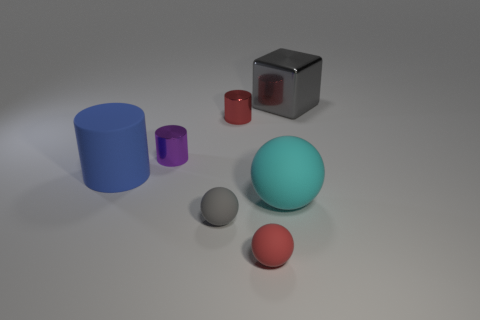There is a gray sphere; what number of tiny things are behind it?
Make the answer very short. 2. What number of things are either gray objects or objects to the left of the small red cylinder?
Give a very brief answer. 4. There is a rubber object left of the small purple metallic object; are there any tiny purple things that are to the right of it?
Provide a short and direct response. Yes. What is the color of the thing that is on the right side of the big cyan object?
Keep it short and to the point. Gray. Is the number of small gray matte spheres that are to the right of the tiny red ball the same as the number of blue objects?
Your answer should be compact. No. There is a big object that is right of the tiny purple metal thing and in front of the tiny red metal object; what is its shape?
Your response must be concise. Sphere. What is the color of the other tiny thing that is the same shape as the small gray thing?
Provide a succinct answer. Red. Are there any other things that are the same color as the big cylinder?
Provide a short and direct response. No. There is a red object that is in front of the gray object in front of the gray thing that is right of the red sphere; what is its shape?
Your response must be concise. Sphere. There is a cylinder in front of the small purple thing; is its size the same as the gray thing behind the blue rubber cylinder?
Give a very brief answer. Yes. 